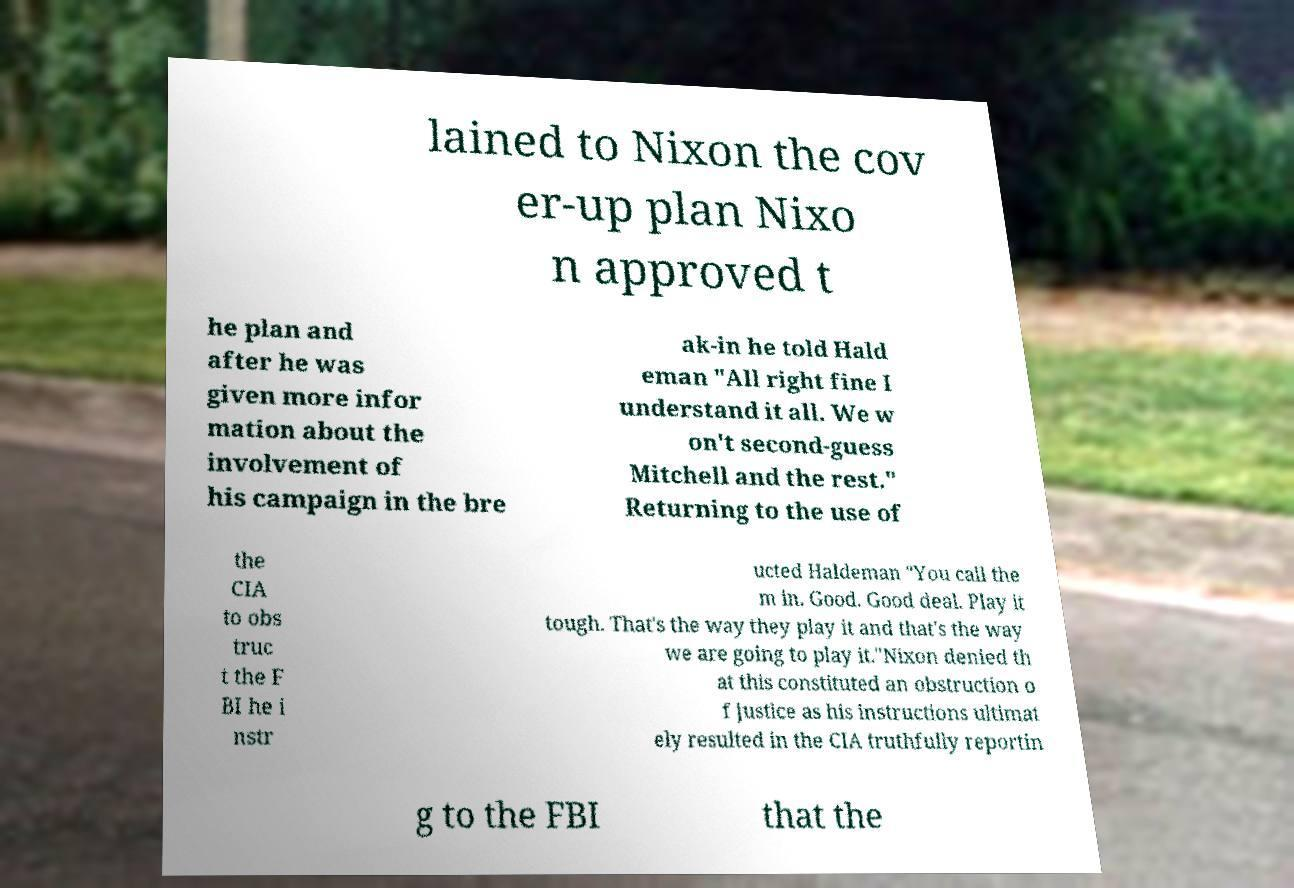Can you accurately transcribe the text from the provided image for me? lained to Nixon the cov er-up plan Nixo n approved t he plan and after he was given more infor mation about the involvement of his campaign in the bre ak-in he told Hald eman "All right fine I understand it all. We w on't second-guess Mitchell and the rest." Returning to the use of the CIA to obs truc t the F BI he i nstr ucted Haldeman "You call the m in. Good. Good deal. Play it tough. That's the way they play it and that's the way we are going to play it."Nixon denied th at this constituted an obstruction o f justice as his instructions ultimat ely resulted in the CIA truthfully reportin g to the FBI that the 